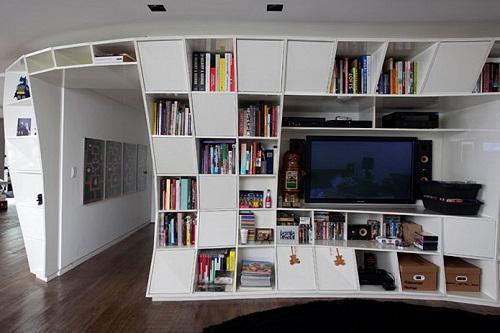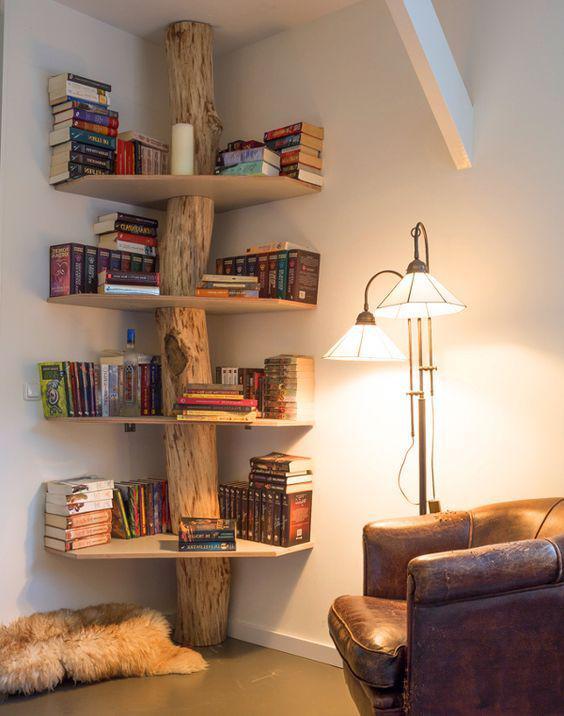The first image is the image on the left, the second image is the image on the right. Given the left and right images, does the statement "A window is visible in at least one of the images." hold true? Answer yes or no. No. The first image is the image on the left, the second image is the image on the right. For the images displayed, is the sentence "An image shows a tree-inspired wooden bookshelf with platform shelves." factually correct? Answer yes or no. Yes. 